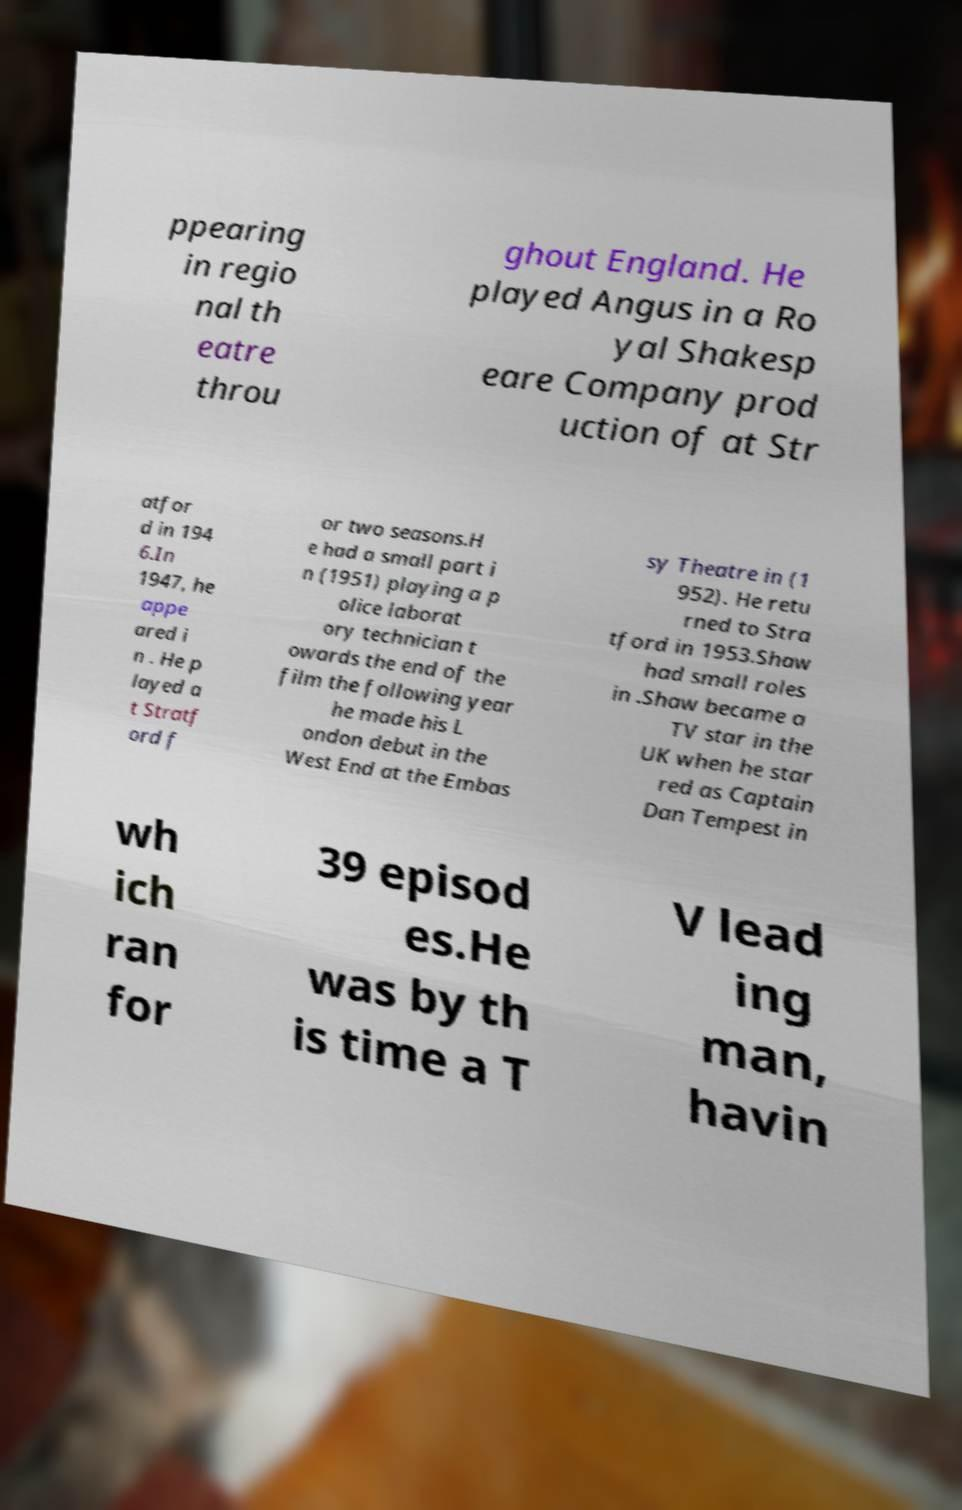Please identify and transcribe the text found in this image. ppearing in regio nal th eatre throu ghout England. He played Angus in a Ro yal Shakesp eare Company prod uction of at Str atfor d in 194 6.In 1947, he appe ared i n . He p layed a t Stratf ord f or two seasons.H e had a small part i n (1951) playing a p olice laborat ory technician t owards the end of the film the following year he made his L ondon debut in the West End at the Embas sy Theatre in (1 952). He retu rned to Stra tford in 1953.Shaw had small roles in .Shaw became a TV star in the UK when he star red as Captain Dan Tempest in wh ich ran for 39 episod es.He was by th is time a T V lead ing man, havin 